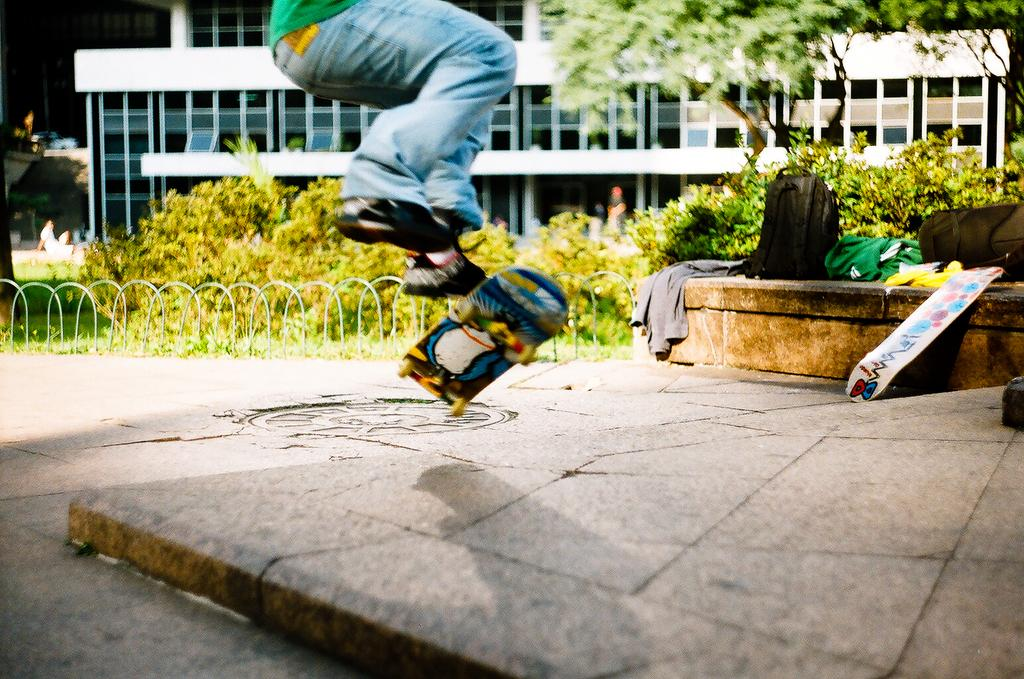What can be seen in the background of the image? There is a building in the background of the image. What is located in front of the building? There are trees in front of the building. What is the person in the image doing? There is a person on a skateboard in the image. What item is the person carrying? There is a backpack visible in the image. What is present on the ground in the image? There are objects on the ground in the image. How many children are present in the image? There is no mention of children in the image; it features a person on a skateboard. What degree does the person on the skateboard have? There is no information about the person's degree in the image. 